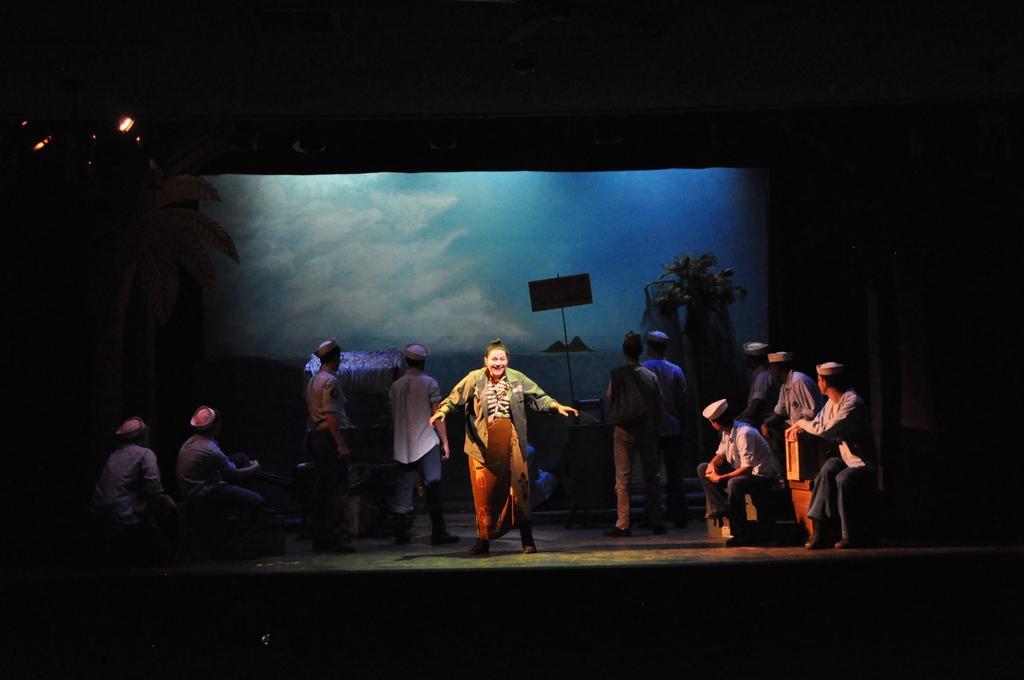Can you describe this image briefly? In this image an act is playing on a stage. 